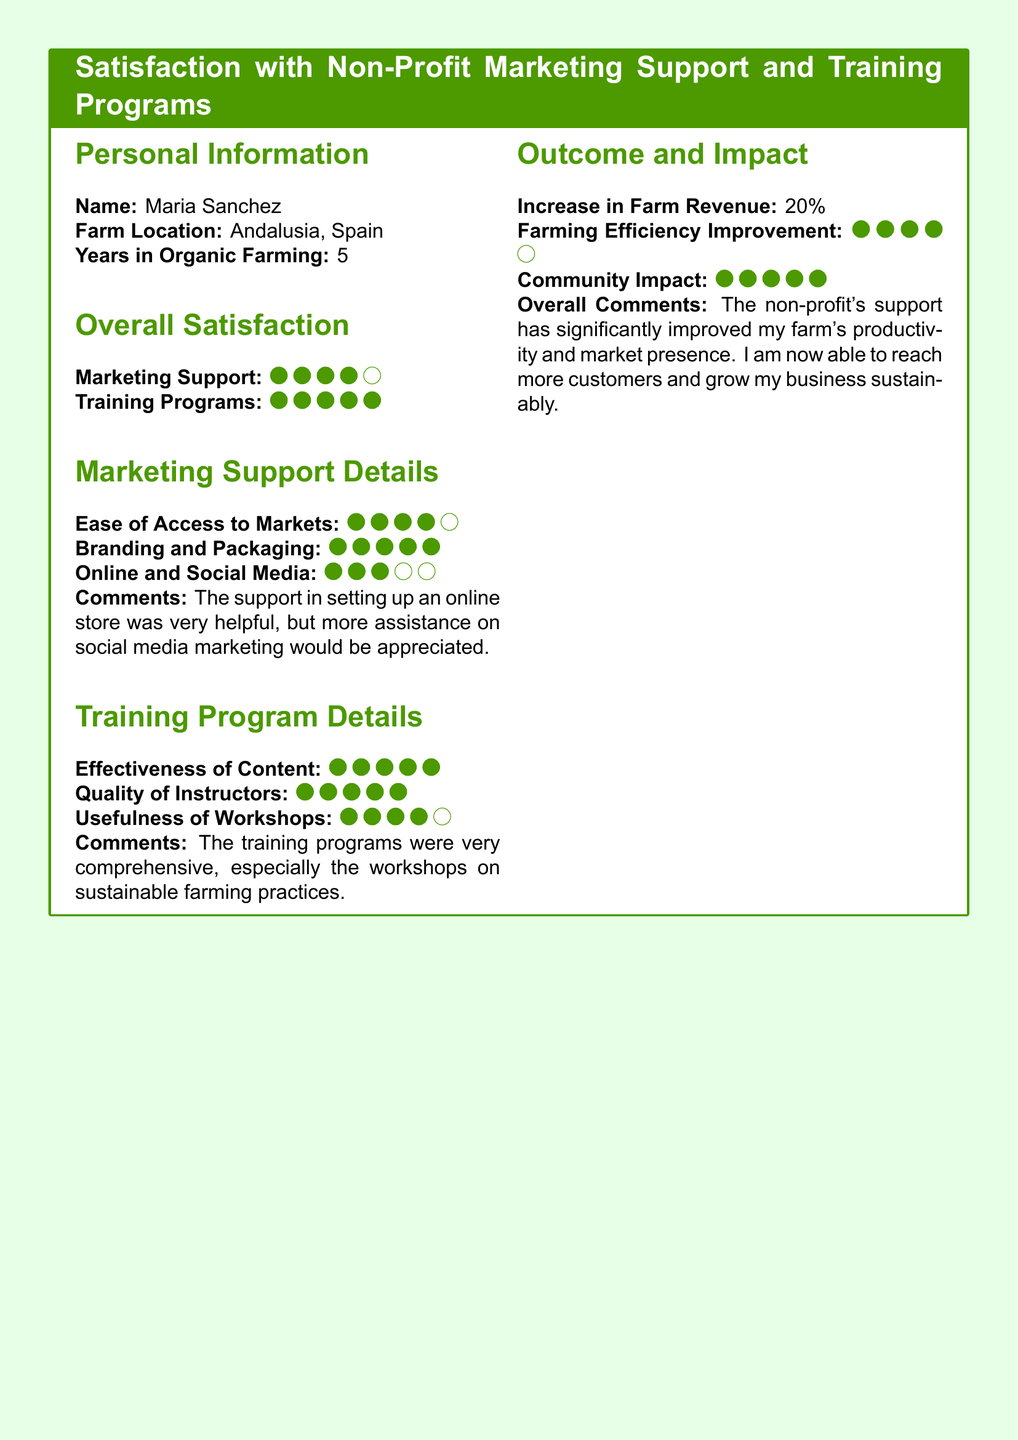What is the name of the respondent? The name of the respondent is provided in the personal information section of the document.
Answer: Maria Sanchez What is the farm location? The farm location is specified under personal information in the document.
Answer: Andalusia, Spain How many years has the respondent been in organic farming? The number of years spent in organic farming is listed in the personal information section.
Answer: 5 What is the overall satisfaction rating for marketing support? The overall satisfaction rating is indicated by the filled and unfilled circles in the marketing support section.
Answer: 4 What percentage increase in farm revenue was reported? The increase in farm revenue is explicitly stated in the outcome and impact section of the document.
Answer: 20% How did the respondent rate the effectiveness of training content? The effectiveness of the training content is represented by the filled circles in the training program details section.
Answer: 5 What topic did the respondent find most useful in the training programs? The comments section provides insights into topics that were particularly helpful.
Answer: Sustainable farming practices What assistance regarding marketing is the respondent seeking? The comments section also outlines additional support desired by the respondent.
Answer: Social media marketing What was the rating for the quality of instructors? The rating for the quality of instructors is represented by the filled circles in the training program details section.
Answer: 5 What is one impact of the non-profit's support mentioned by the respondent? The overall comments section reflects on the broader impacts of the non-profit's support.
Answer: Improved productivity 